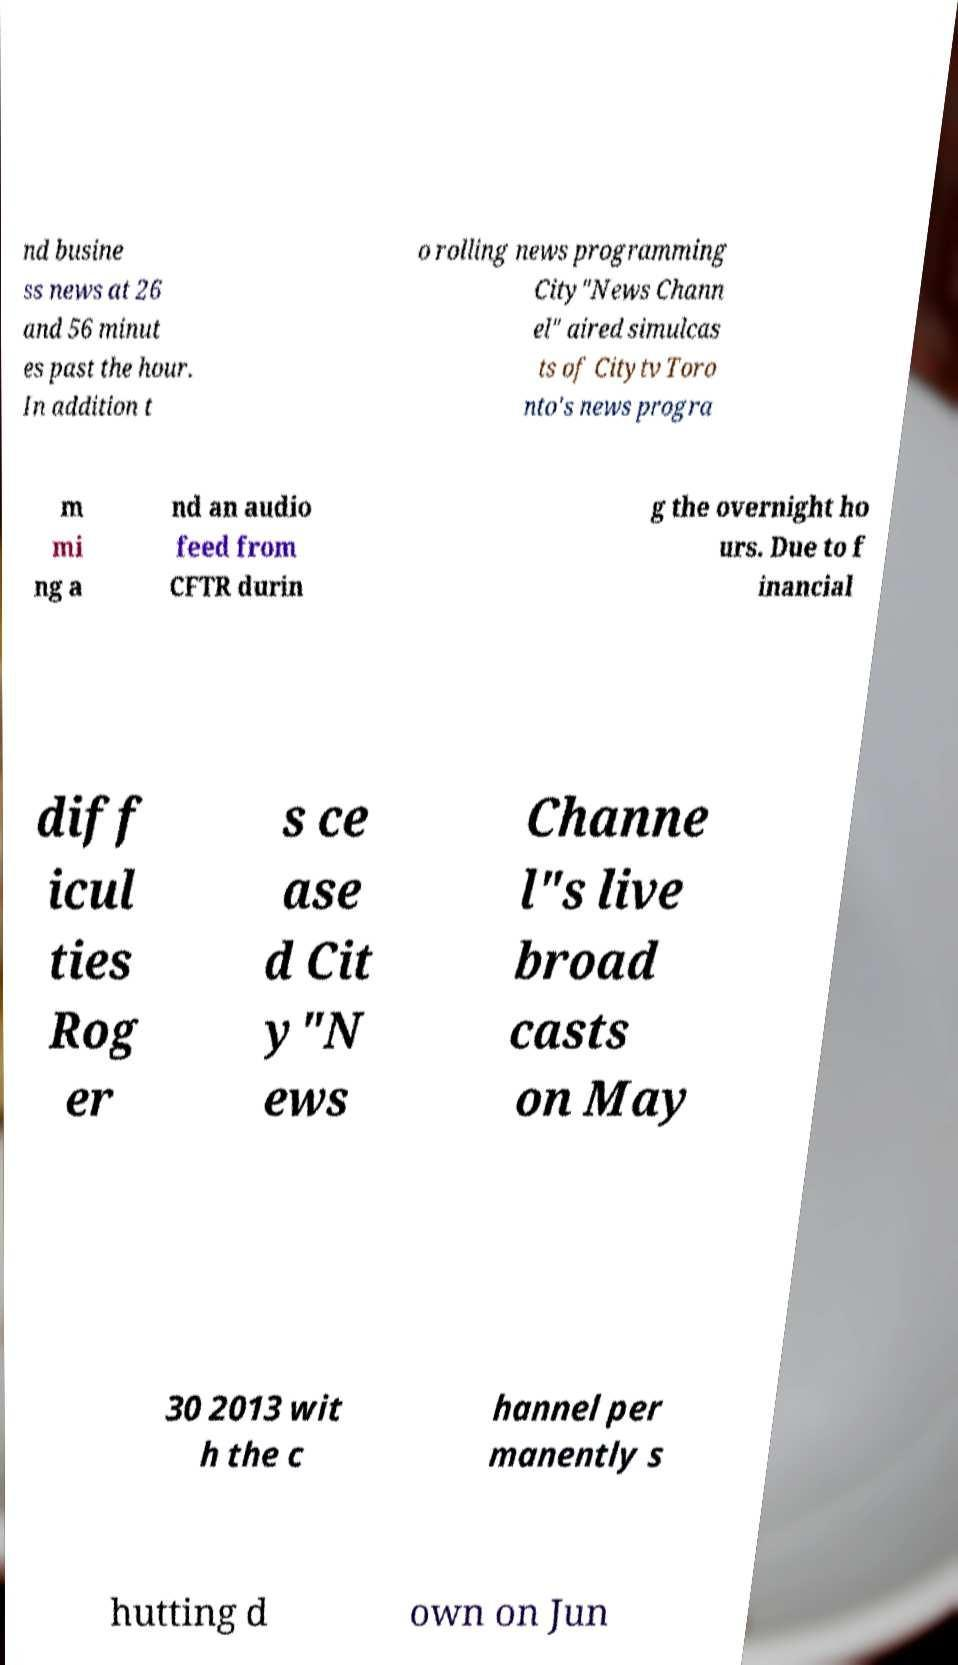For documentation purposes, I need the text within this image transcribed. Could you provide that? nd busine ss news at 26 and 56 minut es past the hour. In addition t o rolling news programming City"News Chann el" aired simulcas ts of Citytv Toro nto's news progra m mi ng a nd an audio feed from CFTR durin g the overnight ho urs. Due to f inancial diff icul ties Rog er s ce ase d Cit y"N ews Channe l"s live broad casts on May 30 2013 wit h the c hannel per manently s hutting d own on Jun 